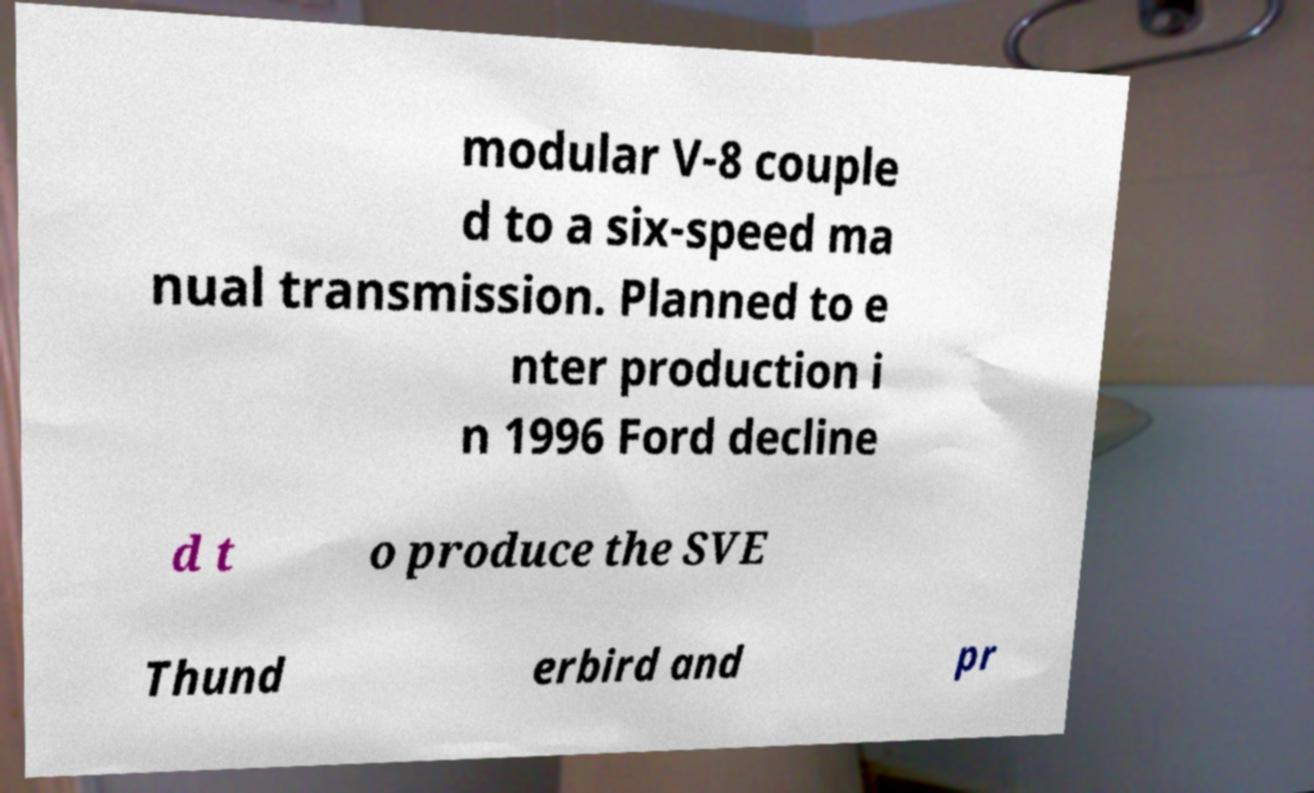I need the written content from this picture converted into text. Can you do that? modular V-8 couple d to a six-speed ma nual transmission. Planned to e nter production i n 1996 Ford decline d t o produce the SVE Thund erbird and pr 